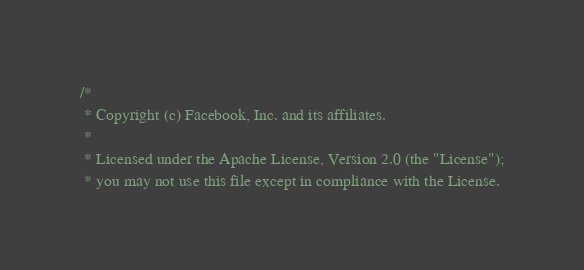<code> <loc_0><loc_0><loc_500><loc_500><_C++_>/*
 * Copyright (c) Facebook, Inc. and its affiliates.
 *
 * Licensed under the Apache License, Version 2.0 (the "License");
 * you may not use this file except in compliance with the License.</code> 